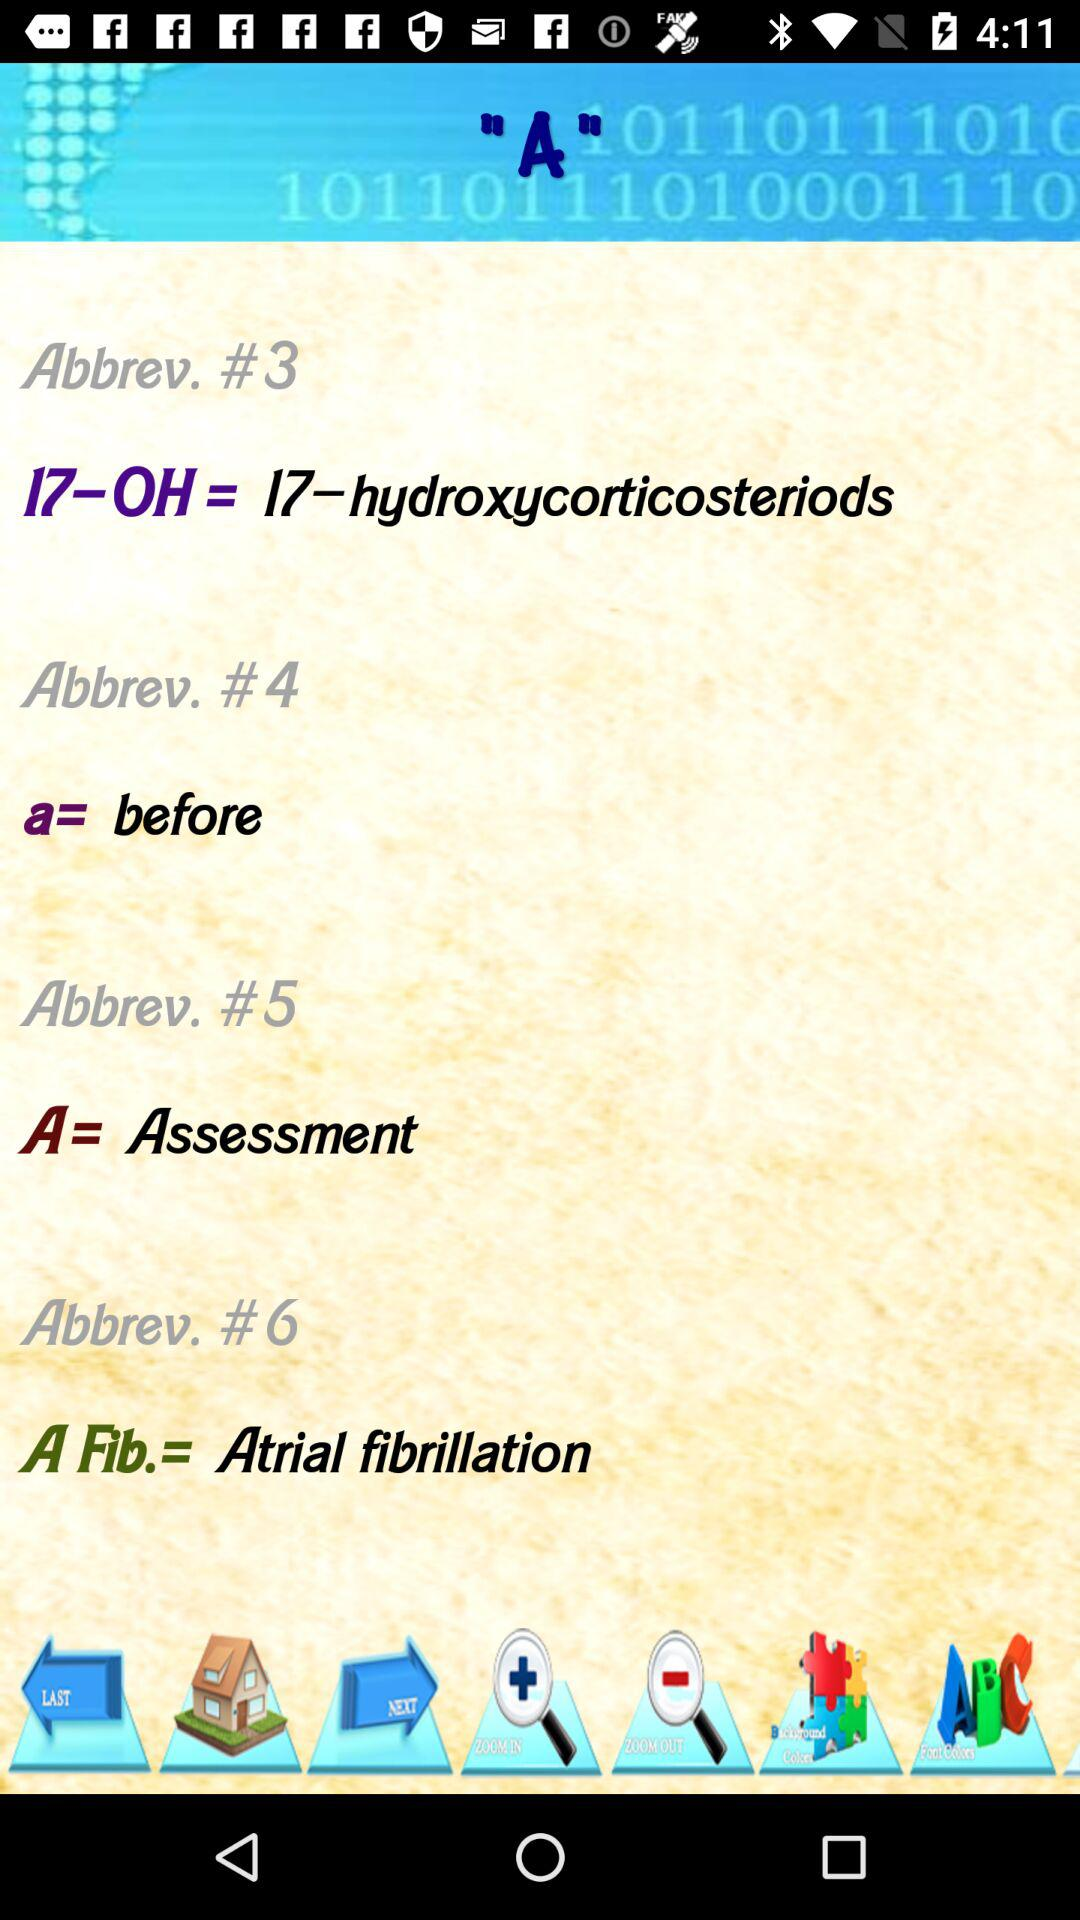What does 17-OH stand for? The 17-OH stands for 17-hydroxycorticosteriods. 